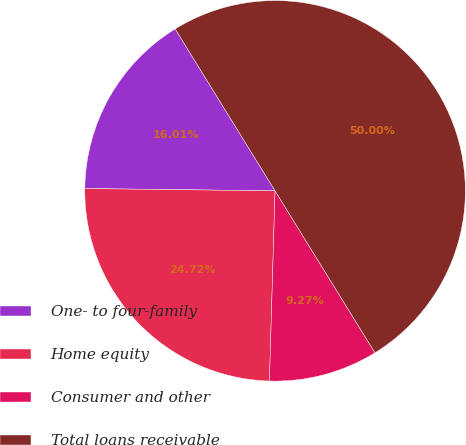Convert chart to OTSL. <chart><loc_0><loc_0><loc_500><loc_500><pie_chart><fcel>One- to four-family<fcel>Home equity<fcel>Consumer and other<fcel>Total loans receivable<nl><fcel>16.01%<fcel>24.72%<fcel>9.27%<fcel>50.0%<nl></chart> 